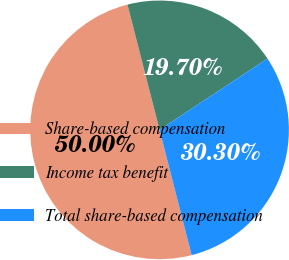Convert chart to OTSL. <chart><loc_0><loc_0><loc_500><loc_500><pie_chart><fcel>Share-based compensation<fcel>Income tax benefit<fcel>Total share-based compensation<nl><fcel>50.0%<fcel>19.7%<fcel>30.3%<nl></chart> 